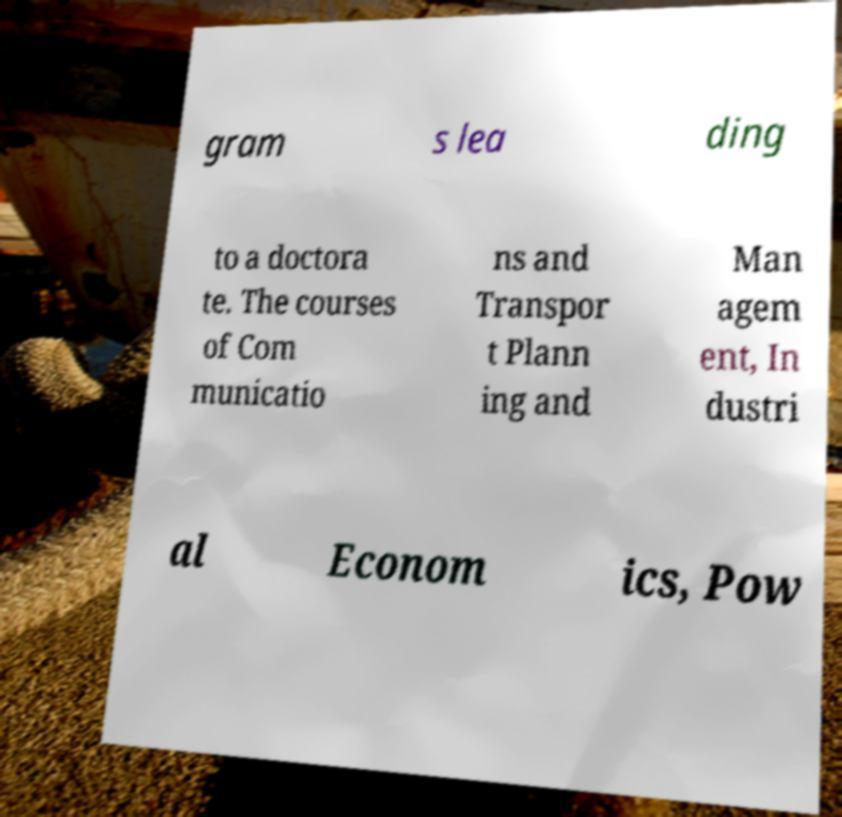Can you read and provide the text displayed in the image?This photo seems to have some interesting text. Can you extract and type it out for me? gram s lea ding to a doctora te. The courses of Com municatio ns and Transpor t Plann ing and Man agem ent, In dustri al Econom ics, Pow 